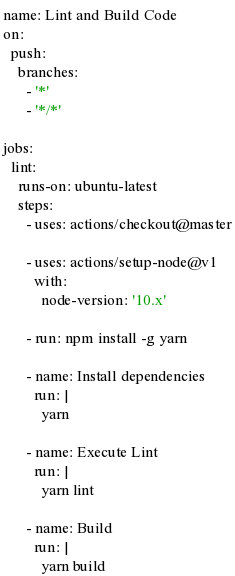Convert code to text. <code><loc_0><loc_0><loc_500><loc_500><_YAML_>name: Lint and Build Code
on:
  push:
    branches:
      - '*'
      - '*/*'

jobs:
  lint:
    runs-on: ubuntu-latest
    steps:
      - uses: actions/checkout@master

      - uses: actions/setup-node@v1
        with:
          node-version: '10.x'

      - run: npm install -g yarn

      - name: Install dependencies
        run: |
          yarn

      - name: Execute Lint
        run: |
          yarn lint

      - name: Build
        run: |
          yarn build
</code> 